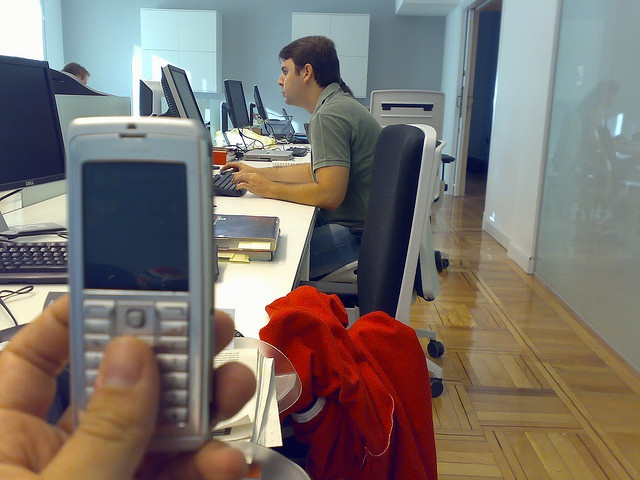Describe the objects in this image and their specific colors. I can see cell phone in white, navy, gray, and darkgray tones, people in white, gray, brown, and maroon tones, people in white, black, gray, and tan tones, chair in white, black, darkgray, and gray tones, and tv in white, navy, black, darkblue, and gray tones in this image. 